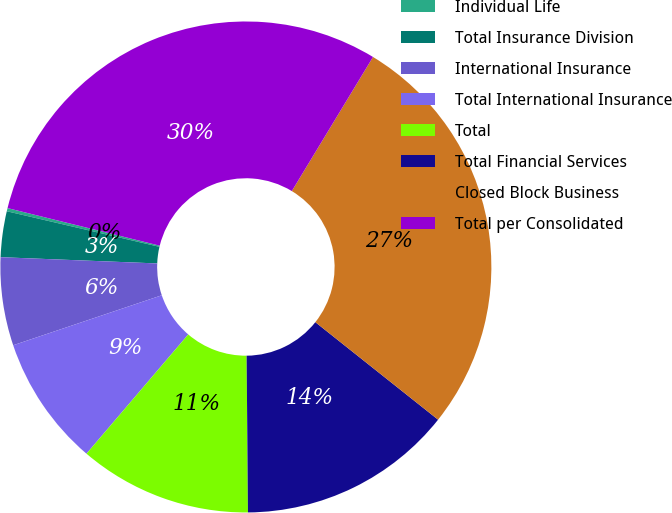<chart> <loc_0><loc_0><loc_500><loc_500><pie_chart><fcel>Individual Life<fcel>Total Insurance Division<fcel>International Insurance<fcel>Total International Insurance<fcel>Total<fcel>Total Financial Services<fcel>Closed Block Business<fcel>Total per Consolidated<nl><fcel>0.21%<fcel>3.01%<fcel>5.8%<fcel>8.59%<fcel>11.38%<fcel>14.18%<fcel>27.02%<fcel>29.81%<nl></chart> 